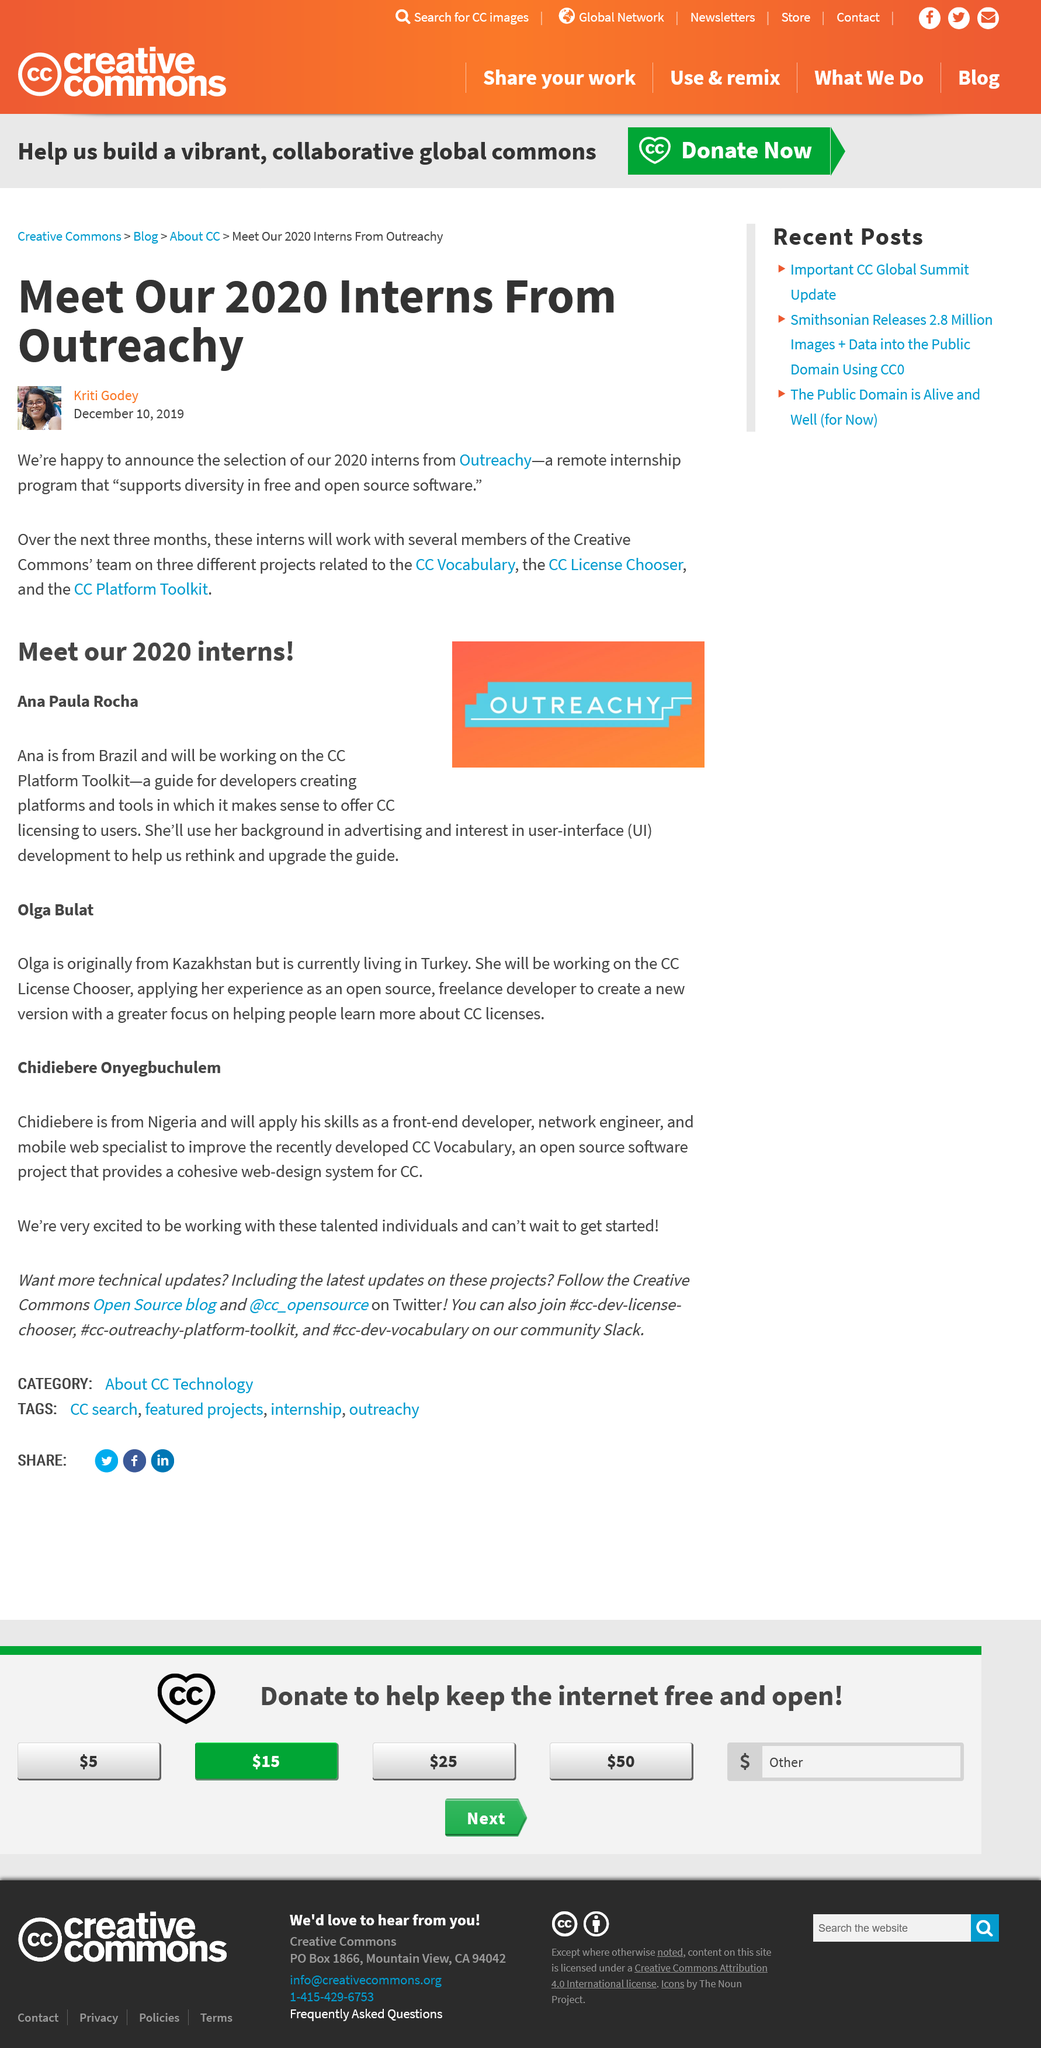Mention a couple of crucial points in this snapshot. The 202 interns from Outreachy were announced on December 10, 2019. The Platform Toolkit is a guide for developers creating platforms and tools, which provides information on when it is appropriate to offer CC licensing to users. The Outreachy interns will work on projects related to the CC Vocabulary, the CC License Choose, and the CC Platform Toolkit, which involve the use of Creative Commons licenses and tools to promote the sharing and use of creative works. Ana Paula Rocha is a Brazilian originating from Brazil. The Outreach interns will be working with several members of the Creative Commons team. 